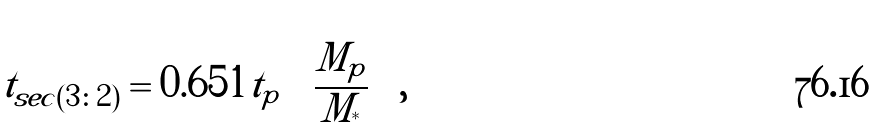Convert formula to latex. <formula><loc_0><loc_0><loc_500><loc_500>t _ { s e c ( 3 \colon 2 ) } = 0 . 6 5 1 t _ { p } \left ( \frac { M _ { p } } { M _ { ^ { * } } } \right ) ,</formula> 